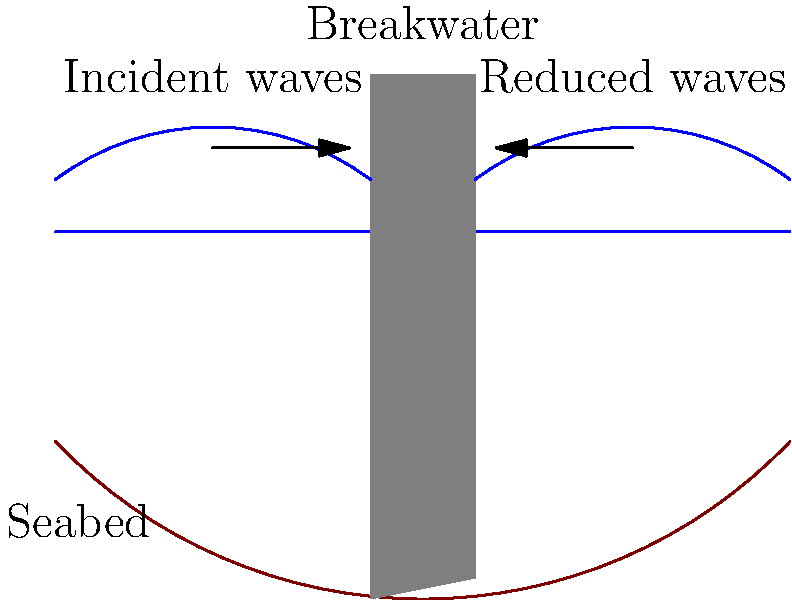As a former Royal Navy expedition member, you are tasked with designing a breakwater structure to protect a harbor from strong waves. The seabed slopes from a depth of 2 meters at the shoreline to 3.5 meters at the proposed breakwater location. If the design wave height is 2 meters and the breakwater is to be constructed using concrete blocks, what is the minimum height of the breakwater above sea level to effectively reduce wave energy by 80%? To determine the minimum height of the breakwater, we'll follow these steps:

1. Consider the design wave height: 2 meters

2. Calculate the wave run-up:
   Wave run-up is typically 1.5 to 2 times the wave height.
   Let's use 1.8 as a conservative factor.
   Wave run-up = 1.8 * 2 meters = 3.6 meters

3. Add a safety factor:
   A common safety factor is 0.5 to 1 meter.
   Let's use 0.7 meters for this case.

4. Calculate the total height above sea level:
   Total height = Wave run-up + Safety factor
   Total height = 3.6 meters + 0.7 meters = 4.3 meters

5. Round up to the nearest 0.5 meters for practical construction:
   Minimum breakwater height = 4.5 meters above sea level

This height ensures that the breakwater will effectively reduce wave energy by at least 80% under the given conditions, considering the design wave height, wave run-up, and a safety factor.
Answer: 4.5 meters 